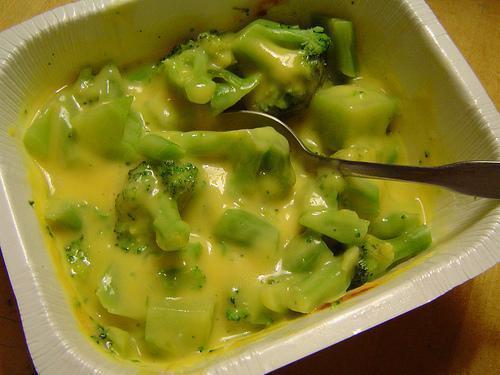How was this dish prepared?
Choose the correct response and explain in the format: 'Answer: answer
Rationale: rationale.'
Options: Microwave, oven, grill, air fryer. Answer: microwave.
Rationale: This is a type of container that is used in one 